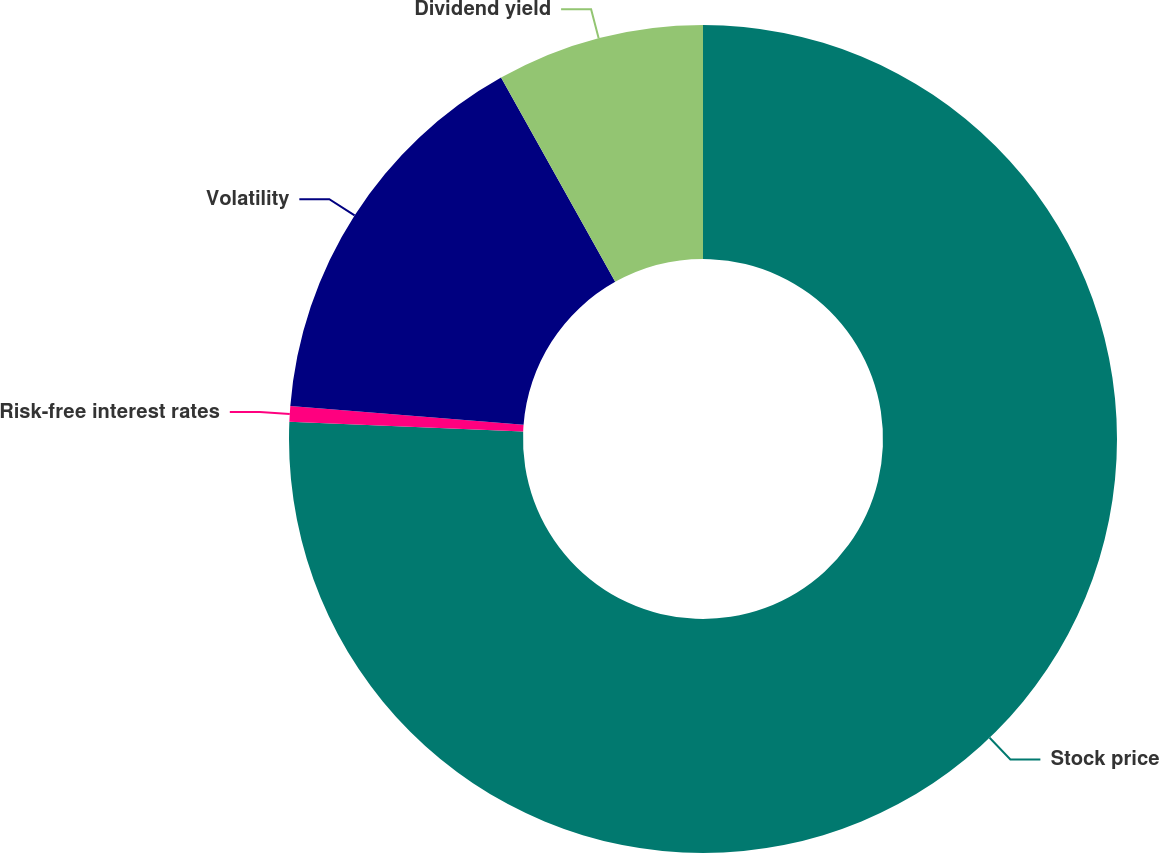Convert chart. <chart><loc_0><loc_0><loc_500><loc_500><pie_chart><fcel>Stock price<fcel>Risk-free interest rates<fcel>Volatility<fcel>Dividend yield<nl><fcel>75.66%<fcel>0.61%<fcel>15.62%<fcel>8.11%<nl></chart> 